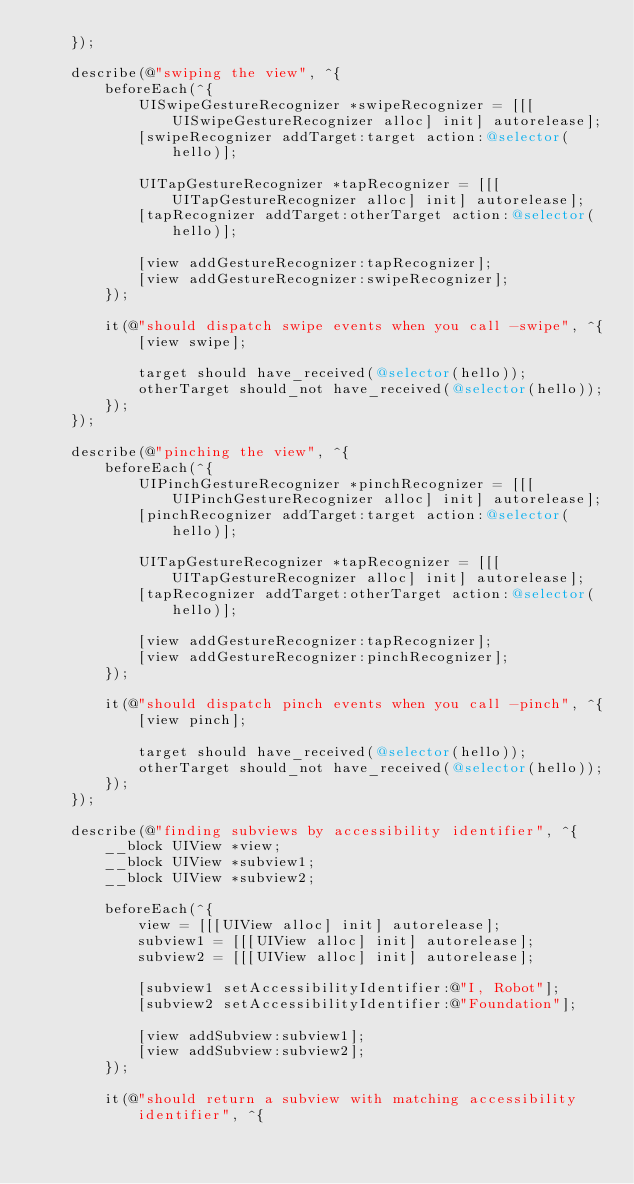Convert code to text. <code><loc_0><loc_0><loc_500><loc_500><_ObjectiveC_>    });

    describe(@"swiping the view", ^{
        beforeEach(^{
            UISwipeGestureRecognizer *swipeRecognizer = [[[UISwipeGestureRecognizer alloc] init] autorelease];
            [swipeRecognizer addTarget:target action:@selector(hello)];

            UITapGestureRecognizer *tapRecognizer = [[[UITapGestureRecognizer alloc] init] autorelease];
            [tapRecognizer addTarget:otherTarget action:@selector(hello)];

            [view addGestureRecognizer:tapRecognizer];
            [view addGestureRecognizer:swipeRecognizer];
        });

        it(@"should dispatch swipe events when you call -swipe", ^{
            [view swipe];

            target should have_received(@selector(hello));
            otherTarget should_not have_received(@selector(hello));
        });
    });

    describe(@"pinching the view", ^{
        beforeEach(^{
            UIPinchGestureRecognizer *pinchRecognizer = [[[UIPinchGestureRecognizer alloc] init] autorelease];
            [pinchRecognizer addTarget:target action:@selector(hello)];

            UITapGestureRecognizer *tapRecognizer = [[[UITapGestureRecognizer alloc] init] autorelease];
            [tapRecognizer addTarget:otherTarget action:@selector(hello)];

            [view addGestureRecognizer:tapRecognizer];
            [view addGestureRecognizer:pinchRecognizer];
        });

        it(@"should dispatch pinch events when you call -pinch", ^{
            [view pinch];

            target should have_received(@selector(hello));
            otherTarget should_not have_received(@selector(hello));
        });
    });

    describe(@"finding subviews by accessibility identifier", ^{
        __block UIView *view;
        __block UIView *subview1;
        __block UIView *subview2;

        beforeEach(^{
            view = [[[UIView alloc] init] autorelease];
            subview1 = [[[UIView alloc] init] autorelease];
            subview2 = [[[UIView alloc] init] autorelease];

            [subview1 setAccessibilityIdentifier:@"I, Robot"];
            [subview2 setAccessibilityIdentifier:@"Foundation"];

            [view addSubview:subview1];
            [view addSubview:subview2];
        });

        it(@"should return a subview with matching accessibility identifier", ^{</code> 